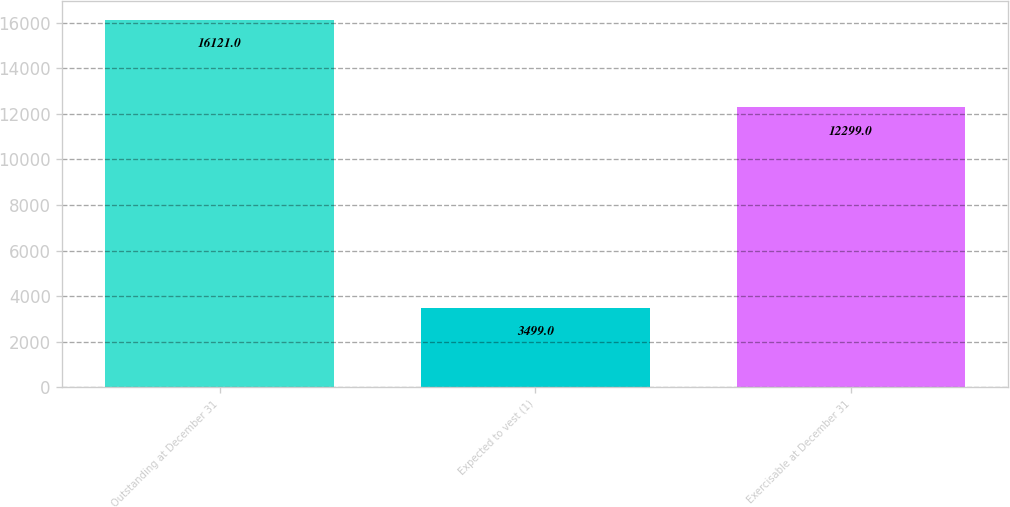<chart> <loc_0><loc_0><loc_500><loc_500><bar_chart><fcel>Outstanding at December 31<fcel>Expected to vest (1)<fcel>Exercisable at December 31<nl><fcel>16121<fcel>3499<fcel>12299<nl></chart> 